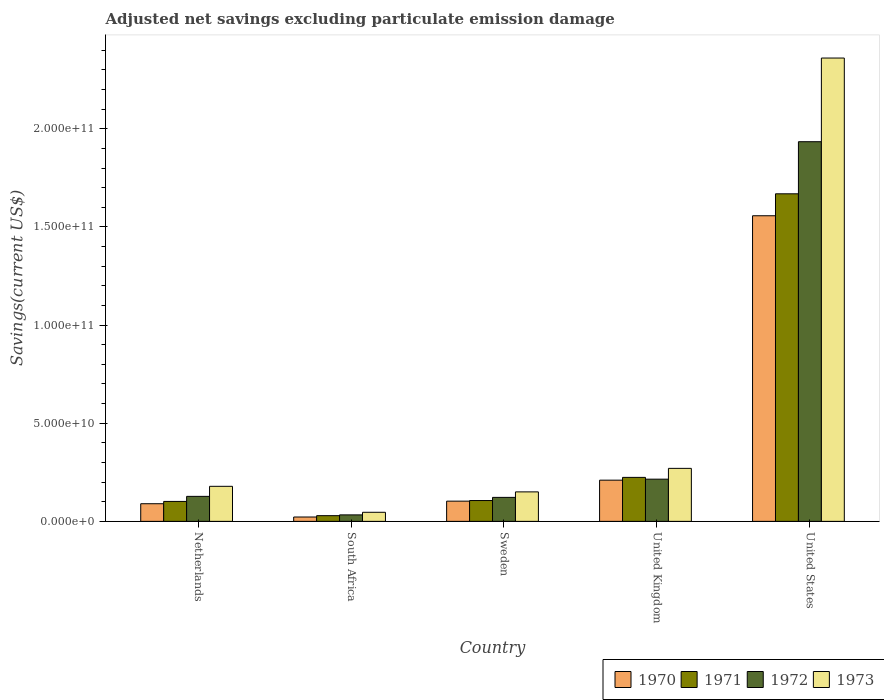How many different coloured bars are there?
Offer a terse response. 4. Are the number of bars per tick equal to the number of legend labels?
Offer a terse response. Yes. Are the number of bars on each tick of the X-axis equal?
Your answer should be compact. Yes. How many bars are there on the 2nd tick from the right?
Your answer should be very brief. 4. What is the adjusted net savings in 1973 in United Kingdom?
Your answer should be compact. 2.70e+1. Across all countries, what is the maximum adjusted net savings in 1971?
Your answer should be very brief. 1.67e+11. Across all countries, what is the minimum adjusted net savings in 1970?
Your response must be concise. 2.22e+09. In which country was the adjusted net savings in 1970 maximum?
Make the answer very short. United States. In which country was the adjusted net savings in 1973 minimum?
Offer a very short reply. South Africa. What is the total adjusted net savings in 1970 in the graph?
Your response must be concise. 1.98e+11. What is the difference between the adjusted net savings in 1973 in Sweden and that in United States?
Make the answer very short. -2.21e+11. What is the difference between the adjusted net savings in 1973 in United States and the adjusted net savings in 1972 in Sweden?
Offer a terse response. 2.24e+11. What is the average adjusted net savings in 1972 per country?
Your answer should be very brief. 4.86e+1. What is the difference between the adjusted net savings of/in 1972 and adjusted net savings of/in 1973 in South Africa?
Your answer should be compact. -1.32e+09. What is the ratio of the adjusted net savings in 1972 in United Kingdom to that in United States?
Your response must be concise. 0.11. Is the difference between the adjusted net savings in 1972 in Netherlands and United Kingdom greater than the difference between the adjusted net savings in 1973 in Netherlands and United Kingdom?
Your answer should be very brief. Yes. What is the difference between the highest and the second highest adjusted net savings in 1972?
Keep it short and to the point. -1.81e+11. What is the difference between the highest and the lowest adjusted net savings in 1973?
Keep it short and to the point. 2.31e+11. In how many countries, is the adjusted net savings in 1972 greater than the average adjusted net savings in 1972 taken over all countries?
Give a very brief answer. 1. Is the sum of the adjusted net savings in 1972 in Netherlands and South Africa greater than the maximum adjusted net savings in 1970 across all countries?
Provide a succinct answer. No. Is it the case that in every country, the sum of the adjusted net savings in 1973 and adjusted net savings in 1972 is greater than the sum of adjusted net savings in 1971 and adjusted net savings in 1970?
Ensure brevity in your answer.  No. What does the 1st bar from the left in United Kingdom represents?
Your answer should be very brief. 1970. What does the 1st bar from the right in Netherlands represents?
Offer a very short reply. 1973. Is it the case that in every country, the sum of the adjusted net savings in 1970 and adjusted net savings in 1973 is greater than the adjusted net savings in 1971?
Offer a very short reply. Yes. How many bars are there?
Provide a succinct answer. 20. How many countries are there in the graph?
Make the answer very short. 5. What is the difference between two consecutive major ticks on the Y-axis?
Provide a short and direct response. 5.00e+1. Does the graph contain grids?
Your answer should be very brief. No. Where does the legend appear in the graph?
Keep it short and to the point. Bottom right. What is the title of the graph?
Offer a terse response. Adjusted net savings excluding particulate emission damage. What is the label or title of the Y-axis?
Make the answer very short. Savings(current US$). What is the Savings(current US$) of 1970 in Netherlands?
Give a very brief answer. 8.99e+09. What is the Savings(current US$) of 1971 in Netherlands?
Your answer should be very brief. 1.02e+1. What is the Savings(current US$) of 1972 in Netherlands?
Offer a very short reply. 1.27e+1. What is the Savings(current US$) of 1973 in Netherlands?
Your answer should be compact. 1.79e+1. What is the Savings(current US$) of 1970 in South Africa?
Give a very brief answer. 2.22e+09. What is the Savings(current US$) of 1971 in South Africa?
Offer a terse response. 2.90e+09. What is the Savings(current US$) of 1972 in South Africa?
Provide a succinct answer. 3.30e+09. What is the Savings(current US$) in 1973 in South Africa?
Provide a succinct answer. 4.62e+09. What is the Savings(current US$) of 1970 in Sweden?
Give a very brief answer. 1.03e+1. What is the Savings(current US$) in 1971 in Sweden?
Give a very brief answer. 1.06e+1. What is the Savings(current US$) of 1972 in Sweden?
Offer a terse response. 1.22e+1. What is the Savings(current US$) in 1973 in Sweden?
Your answer should be very brief. 1.50e+1. What is the Savings(current US$) in 1970 in United Kingdom?
Make the answer very short. 2.10e+1. What is the Savings(current US$) in 1971 in United Kingdom?
Your answer should be very brief. 2.24e+1. What is the Savings(current US$) in 1972 in United Kingdom?
Keep it short and to the point. 2.15e+1. What is the Savings(current US$) of 1973 in United Kingdom?
Your answer should be compact. 2.70e+1. What is the Savings(current US$) of 1970 in United States?
Provide a succinct answer. 1.56e+11. What is the Savings(current US$) of 1971 in United States?
Offer a terse response. 1.67e+11. What is the Savings(current US$) of 1972 in United States?
Make the answer very short. 1.93e+11. What is the Savings(current US$) in 1973 in United States?
Keep it short and to the point. 2.36e+11. Across all countries, what is the maximum Savings(current US$) of 1970?
Offer a terse response. 1.56e+11. Across all countries, what is the maximum Savings(current US$) in 1971?
Make the answer very short. 1.67e+11. Across all countries, what is the maximum Savings(current US$) in 1972?
Your answer should be compact. 1.93e+11. Across all countries, what is the maximum Savings(current US$) in 1973?
Your answer should be compact. 2.36e+11. Across all countries, what is the minimum Savings(current US$) of 1970?
Provide a short and direct response. 2.22e+09. Across all countries, what is the minimum Savings(current US$) in 1971?
Provide a short and direct response. 2.90e+09. Across all countries, what is the minimum Savings(current US$) of 1972?
Your response must be concise. 3.30e+09. Across all countries, what is the minimum Savings(current US$) in 1973?
Your answer should be compact. 4.62e+09. What is the total Savings(current US$) in 1970 in the graph?
Provide a short and direct response. 1.98e+11. What is the total Savings(current US$) of 1971 in the graph?
Your response must be concise. 2.13e+11. What is the total Savings(current US$) of 1972 in the graph?
Your answer should be very brief. 2.43e+11. What is the total Savings(current US$) in 1973 in the graph?
Your answer should be compact. 3.01e+11. What is the difference between the Savings(current US$) of 1970 in Netherlands and that in South Africa?
Offer a terse response. 6.77e+09. What is the difference between the Savings(current US$) in 1971 in Netherlands and that in South Africa?
Your response must be concise. 7.25e+09. What is the difference between the Savings(current US$) in 1972 in Netherlands and that in South Africa?
Give a very brief answer. 9.43e+09. What is the difference between the Savings(current US$) in 1973 in Netherlands and that in South Africa?
Keep it short and to the point. 1.32e+1. What is the difference between the Savings(current US$) of 1970 in Netherlands and that in Sweden?
Your response must be concise. -1.31e+09. What is the difference between the Savings(current US$) of 1971 in Netherlands and that in Sweden?
Give a very brief answer. -4.54e+08. What is the difference between the Savings(current US$) of 1972 in Netherlands and that in Sweden?
Offer a terse response. 5.20e+08. What is the difference between the Savings(current US$) in 1973 in Netherlands and that in Sweden?
Offer a terse response. 2.83e+09. What is the difference between the Savings(current US$) of 1970 in Netherlands and that in United Kingdom?
Your answer should be compact. -1.20e+1. What is the difference between the Savings(current US$) in 1971 in Netherlands and that in United Kingdom?
Ensure brevity in your answer.  -1.22e+1. What is the difference between the Savings(current US$) in 1972 in Netherlands and that in United Kingdom?
Your answer should be compact. -8.76e+09. What is the difference between the Savings(current US$) in 1973 in Netherlands and that in United Kingdom?
Your response must be concise. -9.15e+09. What is the difference between the Savings(current US$) of 1970 in Netherlands and that in United States?
Give a very brief answer. -1.47e+11. What is the difference between the Savings(current US$) of 1971 in Netherlands and that in United States?
Your answer should be very brief. -1.57e+11. What is the difference between the Savings(current US$) in 1972 in Netherlands and that in United States?
Make the answer very short. -1.81e+11. What is the difference between the Savings(current US$) in 1973 in Netherlands and that in United States?
Make the answer very short. -2.18e+11. What is the difference between the Savings(current US$) of 1970 in South Africa and that in Sweden?
Provide a short and direct response. -8.08e+09. What is the difference between the Savings(current US$) of 1971 in South Africa and that in Sweden?
Ensure brevity in your answer.  -7.70e+09. What is the difference between the Savings(current US$) of 1972 in South Africa and that in Sweden?
Provide a succinct answer. -8.91e+09. What is the difference between the Savings(current US$) of 1973 in South Africa and that in Sweden?
Your answer should be very brief. -1.04e+1. What is the difference between the Savings(current US$) in 1970 in South Africa and that in United Kingdom?
Your response must be concise. -1.88e+1. What is the difference between the Savings(current US$) in 1971 in South Africa and that in United Kingdom?
Ensure brevity in your answer.  -1.95e+1. What is the difference between the Savings(current US$) in 1972 in South Africa and that in United Kingdom?
Your answer should be compact. -1.82e+1. What is the difference between the Savings(current US$) in 1973 in South Africa and that in United Kingdom?
Keep it short and to the point. -2.24e+1. What is the difference between the Savings(current US$) in 1970 in South Africa and that in United States?
Provide a succinct answer. -1.53e+11. What is the difference between the Savings(current US$) in 1971 in South Africa and that in United States?
Your answer should be very brief. -1.64e+11. What is the difference between the Savings(current US$) of 1972 in South Africa and that in United States?
Make the answer very short. -1.90e+11. What is the difference between the Savings(current US$) of 1973 in South Africa and that in United States?
Make the answer very short. -2.31e+11. What is the difference between the Savings(current US$) in 1970 in Sweden and that in United Kingdom?
Provide a short and direct response. -1.07e+1. What is the difference between the Savings(current US$) in 1971 in Sweden and that in United Kingdom?
Give a very brief answer. -1.18e+1. What is the difference between the Savings(current US$) of 1972 in Sweden and that in United Kingdom?
Your answer should be very brief. -9.28e+09. What is the difference between the Savings(current US$) of 1973 in Sweden and that in United Kingdom?
Offer a very short reply. -1.20e+1. What is the difference between the Savings(current US$) of 1970 in Sweden and that in United States?
Make the answer very short. -1.45e+11. What is the difference between the Savings(current US$) in 1971 in Sweden and that in United States?
Make the answer very short. -1.56e+11. What is the difference between the Savings(current US$) in 1972 in Sweden and that in United States?
Provide a short and direct response. -1.81e+11. What is the difference between the Savings(current US$) in 1973 in Sweden and that in United States?
Ensure brevity in your answer.  -2.21e+11. What is the difference between the Savings(current US$) in 1970 in United Kingdom and that in United States?
Your answer should be very brief. -1.35e+11. What is the difference between the Savings(current US$) of 1971 in United Kingdom and that in United States?
Keep it short and to the point. -1.44e+11. What is the difference between the Savings(current US$) in 1972 in United Kingdom and that in United States?
Your answer should be compact. -1.72e+11. What is the difference between the Savings(current US$) of 1973 in United Kingdom and that in United States?
Offer a terse response. -2.09e+11. What is the difference between the Savings(current US$) in 1970 in Netherlands and the Savings(current US$) in 1971 in South Africa?
Your answer should be compact. 6.09e+09. What is the difference between the Savings(current US$) in 1970 in Netherlands and the Savings(current US$) in 1972 in South Africa?
Keep it short and to the point. 5.69e+09. What is the difference between the Savings(current US$) of 1970 in Netherlands and the Savings(current US$) of 1973 in South Africa?
Make the answer very short. 4.37e+09. What is the difference between the Savings(current US$) of 1971 in Netherlands and the Savings(current US$) of 1972 in South Africa?
Provide a succinct answer. 6.85e+09. What is the difference between the Savings(current US$) in 1971 in Netherlands and the Savings(current US$) in 1973 in South Africa?
Provide a short and direct response. 5.53e+09. What is the difference between the Savings(current US$) in 1972 in Netherlands and the Savings(current US$) in 1973 in South Africa?
Make the answer very short. 8.11e+09. What is the difference between the Savings(current US$) of 1970 in Netherlands and the Savings(current US$) of 1971 in Sweden?
Provide a succinct answer. -1.62e+09. What is the difference between the Savings(current US$) in 1970 in Netherlands and the Savings(current US$) in 1972 in Sweden?
Make the answer very short. -3.23e+09. What is the difference between the Savings(current US$) in 1970 in Netherlands and the Savings(current US$) in 1973 in Sweden?
Your answer should be very brief. -6.03e+09. What is the difference between the Savings(current US$) of 1971 in Netherlands and the Savings(current US$) of 1972 in Sweden?
Offer a terse response. -2.06e+09. What is the difference between the Savings(current US$) of 1971 in Netherlands and the Savings(current US$) of 1973 in Sweden?
Make the answer very short. -4.86e+09. What is the difference between the Savings(current US$) of 1972 in Netherlands and the Savings(current US$) of 1973 in Sweden?
Give a very brief answer. -2.28e+09. What is the difference between the Savings(current US$) of 1970 in Netherlands and the Savings(current US$) of 1971 in United Kingdom?
Your response must be concise. -1.34e+1. What is the difference between the Savings(current US$) in 1970 in Netherlands and the Savings(current US$) in 1972 in United Kingdom?
Make the answer very short. -1.25e+1. What is the difference between the Savings(current US$) of 1970 in Netherlands and the Savings(current US$) of 1973 in United Kingdom?
Give a very brief answer. -1.80e+1. What is the difference between the Savings(current US$) of 1971 in Netherlands and the Savings(current US$) of 1972 in United Kingdom?
Provide a short and direct response. -1.13e+1. What is the difference between the Savings(current US$) of 1971 in Netherlands and the Savings(current US$) of 1973 in United Kingdom?
Offer a terse response. -1.68e+1. What is the difference between the Savings(current US$) of 1972 in Netherlands and the Savings(current US$) of 1973 in United Kingdom?
Ensure brevity in your answer.  -1.43e+1. What is the difference between the Savings(current US$) in 1970 in Netherlands and the Savings(current US$) in 1971 in United States?
Provide a succinct answer. -1.58e+11. What is the difference between the Savings(current US$) in 1970 in Netherlands and the Savings(current US$) in 1972 in United States?
Your answer should be compact. -1.84e+11. What is the difference between the Savings(current US$) of 1970 in Netherlands and the Savings(current US$) of 1973 in United States?
Offer a terse response. -2.27e+11. What is the difference between the Savings(current US$) in 1971 in Netherlands and the Savings(current US$) in 1972 in United States?
Offer a very short reply. -1.83e+11. What is the difference between the Savings(current US$) in 1971 in Netherlands and the Savings(current US$) in 1973 in United States?
Give a very brief answer. -2.26e+11. What is the difference between the Savings(current US$) of 1972 in Netherlands and the Savings(current US$) of 1973 in United States?
Provide a succinct answer. -2.23e+11. What is the difference between the Savings(current US$) of 1970 in South Africa and the Savings(current US$) of 1971 in Sweden?
Your response must be concise. -8.39e+09. What is the difference between the Savings(current US$) of 1970 in South Africa and the Savings(current US$) of 1972 in Sweden?
Keep it short and to the point. -1.00e+1. What is the difference between the Savings(current US$) of 1970 in South Africa and the Savings(current US$) of 1973 in Sweden?
Keep it short and to the point. -1.28e+1. What is the difference between the Savings(current US$) in 1971 in South Africa and the Savings(current US$) in 1972 in Sweden?
Ensure brevity in your answer.  -9.31e+09. What is the difference between the Savings(current US$) in 1971 in South Africa and the Savings(current US$) in 1973 in Sweden?
Make the answer very short. -1.21e+1. What is the difference between the Savings(current US$) in 1972 in South Africa and the Savings(current US$) in 1973 in Sweden?
Offer a very short reply. -1.17e+1. What is the difference between the Savings(current US$) of 1970 in South Africa and the Savings(current US$) of 1971 in United Kingdom?
Give a very brief answer. -2.02e+1. What is the difference between the Savings(current US$) of 1970 in South Africa and the Savings(current US$) of 1972 in United Kingdom?
Keep it short and to the point. -1.93e+1. What is the difference between the Savings(current US$) in 1970 in South Africa and the Savings(current US$) in 1973 in United Kingdom?
Ensure brevity in your answer.  -2.48e+1. What is the difference between the Savings(current US$) of 1971 in South Africa and the Savings(current US$) of 1972 in United Kingdom?
Keep it short and to the point. -1.86e+1. What is the difference between the Savings(current US$) of 1971 in South Africa and the Savings(current US$) of 1973 in United Kingdom?
Your response must be concise. -2.41e+1. What is the difference between the Savings(current US$) in 1972 in South Africa and the Savings(current US$) in 1973 in United Kingdom?
Your response must be concise. -2.37e+1. What is the difference between the Savings(current US$) in 1970 in South Africa and the Savings(current US$) in 1971 in United States?
Your response must be concise. -1.65e+11. What is the difference between the Savings(current US$) of 1970 in South Africa and the Savings(current US$) of 1972 in United States?
Make the answer very short. -1.91e+11. What is the difference between the Savings(current US$) in 1970 in South Africa and the Savings(current US$) in 1973 in United States?
Give a very brief answer. -2.34e+11. What is the difference between the Savings(current US$) in 1971 in South Africa and the Savings(current US$) in 1972 in United States?
Offer a very short reply. -1.91e+11. What is the difference between the Savings(current US$) in 1971 in South Africa and the Savings(current US$) in 1973 in United States?
Keep it short and to the point. -2.33e+11. What is the difference between the Savings(current US$) in 1972 in South Africa and the Savings(current US$) in 1973 in United States?
Provide a succinct answer. -2.33e+11. What is the difference between the Savings(current US$) in 1970 in Sweden and the Savings(current US$) in 1971 in United Kingdom?
Ensure brevity in your answer.  -1.21e+1. What is the difference between the Savings(current US$) in 1970 in Sweden and the Savings(current US$) in 1972 in United Kingdom?
Offer a terse response. -1.12e+1. What is the difference between the Savings(current US$) in 1970 in Sweden and the Savings(current US$) in 1973 in United Kingdom?
Give a very brief answer. -1.67e+1. What is the difference between the Savings(current US$) of 1971 in Sweden and the Savings(current US$) of 1972 in United Kingdom?
Your response must be concise. -1.09e+1. What is the difference between the Savings(current US$) of 1971 in Sweden and the Savings(current US$) of 1973 in United Kingdom?
Offer a very short reply. -1.64e+1. What is the difference between the Savings(current US$) in 1972 in Sweden and the Savings(current US$) in 1973 in United Kingdom?
Ensure brevity in your answer.  -1.48e+1. What is the difference between the Savings(current US$) in 1970 in Sweden and the Savings(current US$) in 1971 in United States?
Your response must be concise. -1.57e+11. What is the difference between the Savings(current US$) in 1970 in Sweden and the Savings(current US$) in 1972 in United States?
Keep it short and to the point. -1.83e+11. What is the difference between the Savings(current US$) of 1970 in Sweden and the Savings(current US$) of 1973 in United States?
Make the answer very short. -2.26e+11. What is the difference between the Savings(current US$) in 1971 in Sweden and the Savings(current US$) in 1972 in United States?
Make the answer very short. -1.83e+11. What is the difference between the Savings(current US$) in 1971 in Sweden and the Savings(current US$) in 1973 in United States?
Make the answer very short. -2.25e+11. What is the difference between the Savings(current US$) of 1972 in Sweden and the Savings(current US$) of 1973 in United States?
Offer a very short reply. -2.24e+11. What is the difference between the Savings(current US$) of 1970 in United Kingdom and the Savings(current US$) of 1971 in United States?
Provide a succinct answer. -1.46e+11. What is the difference between the Savings(current US$) of 1970 in United Kingdom and the Savings(current US$) of 1972 in United States?
Ensure brevity in your answer.  -1.72e+11. What is the difference between the Savings(current US$) of 1970 in United Kingdom and the Savings(current US$) of 1973 in United States?
Keep it short and to the point. -2.15e+11. What is the difference between the Savings(current US$) in 1971 in United Kingdom and the Savings(current US$) in 1972 in United States?
Your answer should be compact. -1.71e+11. What is the difference between the Savings(current US$) in 1971 in United Kingdom and the Savings(current US$) in 1973 in United States?
Your response must be concise. -2.14e+11. What is the difference between the Savings(current US$) in 1972 in United Kingdom and the Savings(current US$) in 1973 in United States?
Offer a very short reply. -2.15e+11. What is the average Savings(current US$) of 1970 per country?
Your answer should be very brief. 3.96e+1. What is the average Savings(current US$) in 1971 per country?
Offer a terse response. 4.26e+1. What is the average Savings(current US$) of 1972 per country?
Your answer should be compact. 4.86e+1. What is the average Savings(current US$) of 1973 per country?
Give a very brief answer. 6.01e+1. What is the difference between the Savings(current US$) of 1970 and Savings(current US$) of 1971 in Netherlands?
Keep it short and to the point. -1.17e+09. What is the difference between the Savings(current US$) in 1970 and Savings(current US$) in 1972 in Netherlands?
Keep it short and to the point. -3.75e+09. What is the difference between the Savings(current US$) of 1970 and Savings(current US$) of 1973 in Netherlands?
Your response must be concise. -8.86e+09. What is the difference between the Savings(current US$) in 1971 and Savings(current US$) in 1972 in Netherlands?
Your answer should be compact. -2.58e+09. What is the difference between the Savings(current US$) in 1971 and Savings(current US$) in 1973 in Netherlands?
Give a very brief answer. -7.70e+09. What is the difference between the Savings(current US$) in 1972 and Savings(current US$) in 1973 in Netherlands?
Your answer should be very brief. -5.11e+09. What is the difference between the Savings(current US$) in 1970 and Savings(current US$) in 1971 in South Africa?
Provide a succinct answer. -6.85e+08. What is the difference between the Savings(current US$) in 1970 and Savings(current US$) in 1972 in South Africa?
Offer a very short reply. -1.08e+09. What is the difference between the Savings(current US$) in 1970 and Savings(current US$) in 1973 in South Africa?
Your answer should be very brief. -2.40e+09. What is the difference between the Savings(current US$) in 1971 and Savings(current US$) in 1972 in South Africa?
Your response must be concise. -4.00e+08. What is the difference between the Savings(current US$) in 1971 and Savings(current US$) in 1973 in South Africa?
Your answer should be very brief. -1.72e+09. What is the difference between the Savings(current US$) in 1972 and Savings(current US$) in 1973 in South Africa?
Offer a very short reply. -1.32e+09. What is the difference between the Savings(current US$) of 1970 and Savings(current US$) of 1971 in Sweden?
Offer a very short reply. -3.10e+08. What is the difference between the Savings(current US$) in 1970 and Savings(current US$) in 1972 in Sweden?
Your answer should be compact. -1.92e+09. What is the difference between the Savings(current US$) in 1970 and Savings(current US$) in 1973 in Sweden?
Offer a terse response. -4.72e+09. What is the difference between the Savings(current US$) of 1971 and Savings(current US$) of 1972 in Sweden?
Offer a very short reply. -1.61e+09. What is the difference between the Savings(current US$) of 1971 and Savings(current US$) of 1973 in Sweden?
Ensure brevity in your answer.  -4.41e+09. What is the difference between the Savings(current US$) in 1972 and Savings(current US$) in 1973 in Sweden?
Offer a terse response. -2.80e+09. What is the difference between the Savings(current US$) of 1970 and Savings(current US$) of 1971 in United Kingdom?
Your response must be concise. -1.41e+09. What is the difference between the Savings(current US$) of 1970 and Savings(current US$) of 1972 in United Kingdom?
Your answer should be compact. -5.08e+08. What is the difference between the Savings(current US$) in 1970 and Savings(current US$) in 1973 in United Kingdom?
Ensure brevity in your answer.  -6.01e+09. What is the difference between the Savings(current US$) in 1971 and Savings(current US$) in 1972 in United Kingdom?
Your response must be concise. 9.03e+08. What is the difference between the Savings(current US$) of 1971 and Savings(current US$) of 1973 in United Kingdom?
Give a very brief answer. -4.60e+09. What is the difference between the Savings(current US$) of 1972 and Savings(current US$) of 1973 in United Kingdom?
Offer a very short reply. -5.50e+09. What is the difference between the Savings(current US$) in 1970 and Savings(current US$) in 1971 in United States?
Make the answer very short. -1.12e+1. What is the difference between the Savings(current US$) of 1970 and Savings(current US$) of 1972 in United States?
Ensure brevity in your answer.  -3.77e+1. What is the difference between the Savings(current US$) of 1970 and Savings(current US$) of 1973 in United States?
Your response must be concise. -8.03e+1. What is the difference between the Savings(current US$) in 1971 and Savings(current US$) in 1972 in United States?
Provide a short and direct response. -2.65e+1. What is the difference between the Savings(current US$) of 1971 and Savings(current US$) of 1973 in United States?
Provide a succinct answer. -6.92e+1. What is the difference between the Savings(current US$) in 1972 and Savings(current US$) in 1973 in United States?
Provide a short and direct response. -4.26e+1. What is the ratio of the Savings(current US$) in 1970 in Netherlands to that in South Africa?
Provide a short and direct response. 4.05. What is the ratio of the Savings(current US$) of 1971 in Netherlands to that in South Africa?
Provide a short and direct response. 3.5. What is the ratio of the Savings(current US$) of 1972 in Netherlands to that in South Africa?
Offer a very short reply. 3.86. What is the ratio of the Savings(current US$) of 1973 in Netherlands to that in South Africa?
Offer a very short reply. 3.86. What is the ratio of the Savings(current US$) of 1970 in Netherlands to that in Sweden?
Provide a succinct answer. 0.87. What is the ratio of the Savings(current US$) of 1971 in Netherlands to that in Sweden?
Ensure brevity in your answer.  0.96. What is the ratio of the Savings(current US$) of 1972 in Netherlands to that in Sweden?
Keep it short and to the point. 1.04. What is the ratio of the Savings(current US$) of 1973 in Netherlands to that in Sweden?
Offer a very short reply. 1.19. What is the ratio of the Savings(current US$) in 1970 in Netherlands to that in United Kingdom?
Your answer should be compact. 0.43. What is the ratio of the Savings(current US$) of 1971 in Netherlands to that in United Kingdom?
Your answer should be very brief. 0.45. What is the ratio of the Savings(current US$) in 1972 in Netherlands to that in United Kingdom?
Make the answer very short. 0.59. What is the ratio of the Savings(current US$) in 1973 in Netherlands to that in United Kingdom?
Provide a short and direct response. 0.66. What is the ratio of the Savings(current US$) of 1970 in Netherlands to that in United States?
Offer a very short reply. 0.06. What is the ratio of the Savings(current US$) in 1971 in Netherlands to that in United States?
Make the answer very short. 0.06. What is the ratio of the Savings(current US$) of 1972 in Netherlands to that in United States?
Ensure brevity in your answer.  0.07. What is the ratio of the Savings(current US$) in 1973 in Netherlands to that in United States?
Give a very brief answer. 0.08. What is the ratio of the Savings(current US$) in 1970 in South Africa to that in Sweden?
Provide a short and direct response. 0.22. What is the ratio of the Savings(current US$) in 1971 in South Africa to that in Sweden?
Offer a terse response. 0.27. What is the ratio of the Savings(current US$) in 1972 in South Africa to that in Sweden?
Offer a very short reply. 0.27. What is the ratio of the Savings(current US$) in 1973 in South Africa to that in Sweden?
Ensure brevity in your answer.  0.31. What is the ratio of the Savings(current US$) of 1970 in South Africa to that in United Kingdom?
Make the answer very short. 0.11. What is the ratio of the Savings(current US$) in 1971 in South Africa to that in United Kingdom?
Your answer should be very brief. 0.13. What is the ratio of the Savings(current US$) of 1972 in South Africa to that in United Kingdom?
Give a very brief answer. 0.15. What is the ratio of the Savings(current US$) of 1973 in South Africa to that in United Kingdom?
Provide a succinct answer. 0.17. What is the ratio of the Savings(current US$) of 1970 in South Africa to that in United States?
Offer a terse response. 0.01. What is the ratio of the Savings(current US$) in 1971 in South Africa to that in United States?
Provide a succinct answer. 0.02. What is the ratio of the Savings(current US$) in 1972 in South Africa to that in United States?
Ensure brevity in your answer.  0.02. What is the ratio of the Savings(current US$) of 1973 in South Africa to that in United States?
Make the answer very short. 0.02. What is the ratio of the Savings(current US$) of 1970 in Sweden to that in United Kingdom?
Make the answer very short. 0.49. What is the ratio of the Savings(current US$) in 1971 in Sweden to that in United Kingdom?
Provide a short and direct response. 0.47. What is the ratio of the Savings(current US$) in 1972 in Sweden to that in United Kingdom?
Keep it short and to the point. 0.57. What is the ratio of the Savings(current US$) in 1973 in Sweden to that in United Kingdom?
Give a very brief answer. 0.56. What is the ratio of the Savings(current US$) in 1970 in Sweden to that in United States?
Offer a terse response. 0.07. What is the ratio of the Savings(current US$) in 1971 in Sweden to that in United States?
Your answer should be compact. 0.06. What is the ratio of the Savings(current US$) in 1972 in Sweden to that in United States?
Provide a succinct answer. 0.06. What is the ratio of the Savings(current US$) in 1973 in Sweden to that in United States?
Ensure brevity in your answer.  0.06. What is the ratio of the Savings(current US$) of 1970 in United Kingdom to that in United States?
Provide a short and direct response. 0.13. What is the ratio of the Savings(current US$) in 1971 in United Kingdom to that in United States?
Keep it short and to the point. 0.13. What is the ratio of the Savings(current US$) in 1972 in United Kingdom to that in United States?
Give a very brief answer. 0.11. What is the ratio of the Savings(current US$) of 1973 in United Kingdom to that in United States?
Your answer should be compact. 0.11. What is the difference between the highest and the second highest Savings(current US$) in 1970?
Your answer should be compact. 1.35e+11. What is the difference between the highest and the second highest Savings(current US$) of 1971?
Give a very brief answer. 1.44e+11. What is the difference between the highest and the second highest Savings(current US$) in 1972?
Your answer should be very brief. 1.72e+11. What is the difference between the highest and the second highest Savings(current US$) of 1973?
Offer a terse response. 2.09e+11. What is the difference between the highest and the lowest Savings(current US$) of 1970?
Give a very brief answer. 1.53e+11. What is the difference between the highest and the lowest Savings(current US$) in 1971?
Your response must be concise. 1.64e+11. What is the difference between the highest and the lowest Savings(current US$) in 1972?
Your response must be concise. 1.90e+11. What is the difference between the highest and the lowest Savings(current US$) of 1973?
Your answer should be very brief. 2.31e+11. 